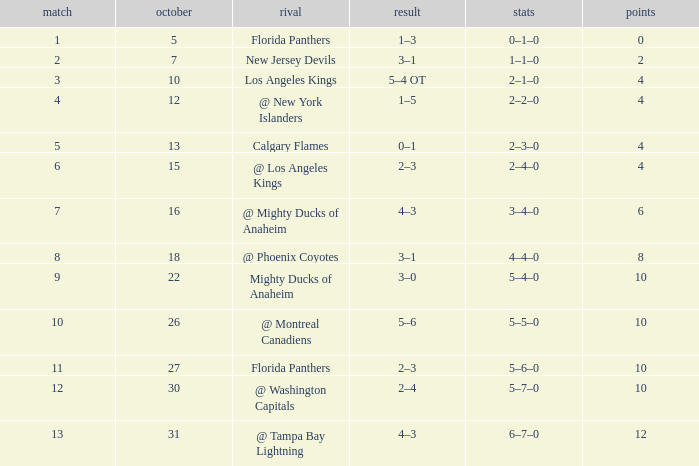Can you give me this table as a dict? {'header': ['match', 'october', 'rival', 'result', 'stats', 'points'], 'rows': [['1', '5', 'Florida Panthers', '1–3', '0–1–0', '0'], ['2', '7', 'New Jersey Devils', '3–1', '1–1–0', '2'], ['3', '10', 'Los Angeles Kings', '5–4 OT', '2–1–0', '4'], ['4', '12', '@ New York Islanders', '1–5', '2–2–0', '4'], ['5', '13', 'Calgary Flames', '0–1', '2–3–0', '4'], ['6', '15', '@ Los Angeles Kings', '2–3', '2–4–0', '4'], ['7', '16', '@ Mighty Ducks of Anaheim', '4–3', '3–4–0', '6'], ['8', '18', '@ Phoenix Coyotes', '3–1', '4–4–0', '8'], ['9', '22', 'Mighty Ducks of Anaheim', '3–0', '5–4–0', '10'], ['10', '26', '@ Montreal Canadiens', '5–6', '5–5–0', '10'], ['11', '27', 'Florida Panthers', '2–3', '5–6–0', '10'], ['12', '30', '@ Washington Capitals', '2–4', '5–7–0', '10'], ['13', '31', '@ Tampa Bay Lightning', '4–3', '6–7–0', '12']]} What team has a score of 11 5–6–0. 